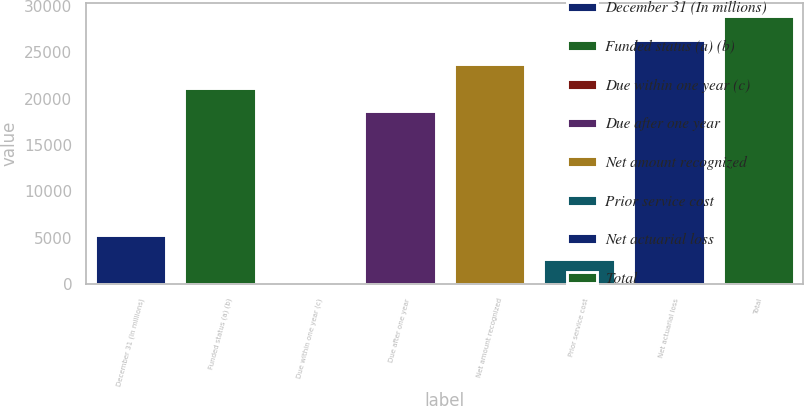<chart> <loc_0><loc_0><loc_500><loc_500><bar_chart><fcel>December 31 (In millions)<fcel>Funded status (a) (b)<fcel>Due within one year (c)<fcel>Due after one year<fcel>Net amount recognized<fcel>Prior service cost<fcel>Net actuarial loss<fcel>Total<nl><fcel>5295.8<fcel>21173.4<fcel>159<fcel>18605<fcel>23741.8<fcel>2727.4<fcel>26310.2<fcel>28878.6<nl></chart> 